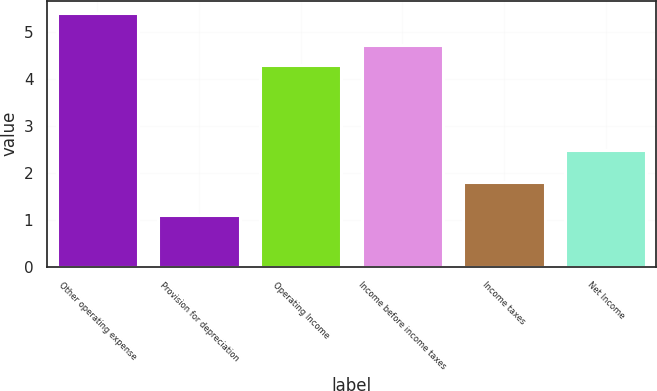Convert chart. <chart><loc_0><loc_0><loc_500><loc_500><bar_chart><fcel>Other operating expense<fcel>Provision for depreciation<fcel>Operating Income<fcel>Income before income taxes<fcel>Income taxes<fcel>Net Income<nl><fcel>5.4<fcel>1.1<fcel>4.3<fcel>4.73<fcel>1.8<fcel>2.5<nl></chart> 